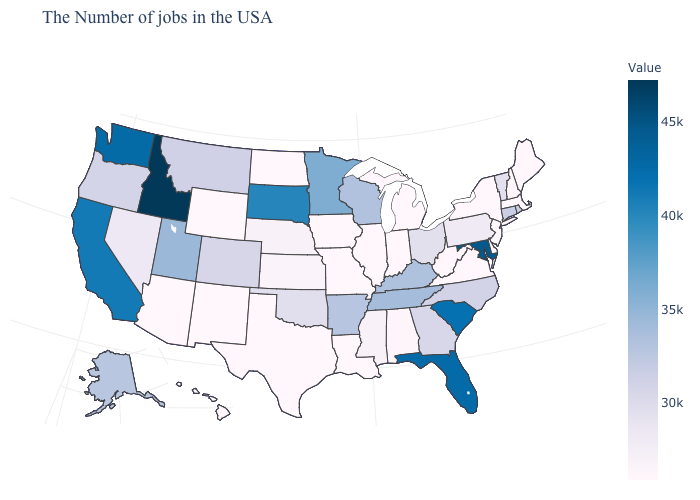Does Arkansas have a lower value than Florida?
Quick response, please. Yes. Which states have the lowest value in the West?
Keep it brief. Wyoming, New Mexico, Arizona, Hawaii. Among the states that border Michigan , does Indiana have the lowest value?
Give a very brief answer. Yes. Which states hav the highest value in the West?
Quick response, please. Idaho. Does South Carolina have a higher value than Idaho?
Give a very brief answer. No. 